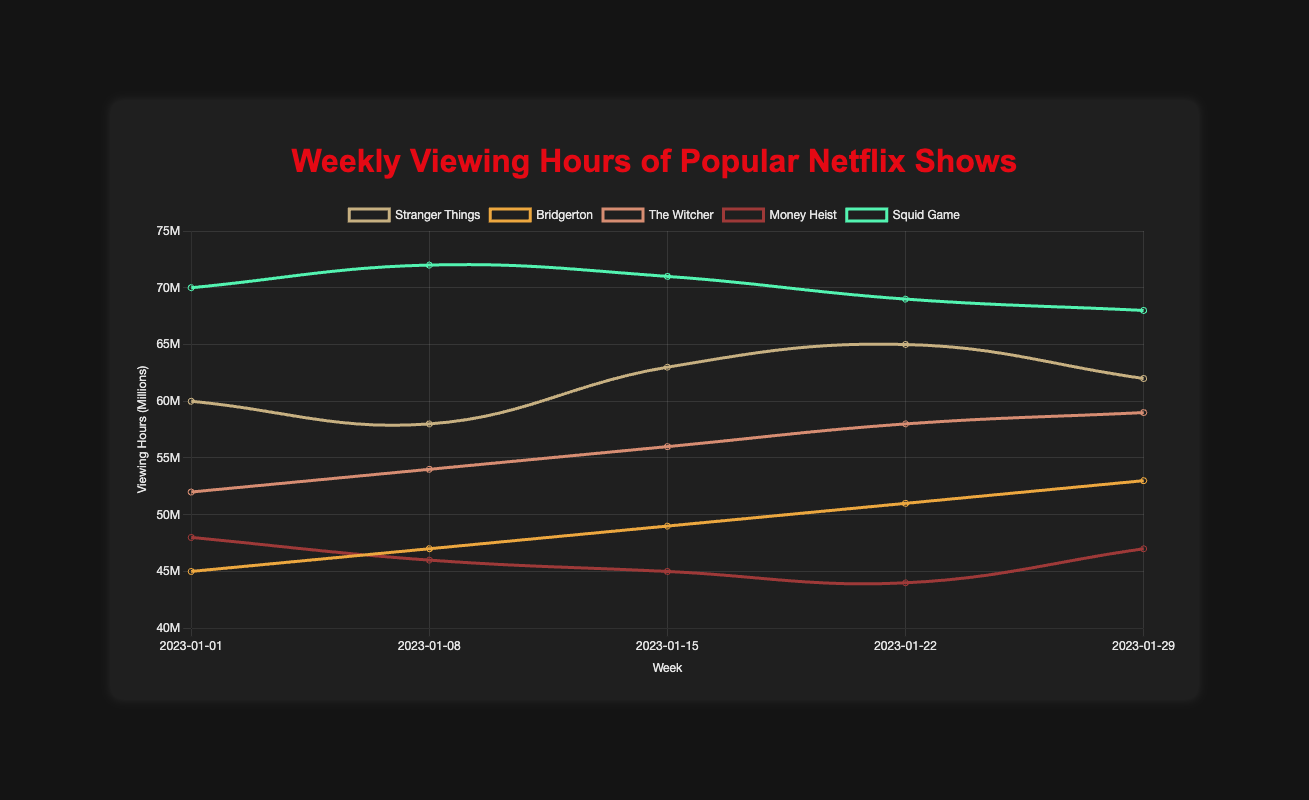Which show had the highest viewing hours at the beginning of January 2023? Look at the viewing hours for the week of "2023-01-01" for each show. "Squid Game" has the highest at 70 million hours.
Answer: Squid Game Which show experienced the greatest increase in viewing hours from January 1 to January 29, 2023? Calculate the difference between the viewing hours on "2023-01-29" and "2023-01-01" for each show: Stranger Things (62000000 - 60000000 = 2000000), Bridgerton (53000000 - 45000000 = 8000000), The Witcher (59000000 - 52000000 = 7000000), Money Heist (47000000 - 48000000 = -1000000), Squid Game (68000000 - 70000000 = -2000000). Bridgerton had the greatest increase.
Answer: Bridgerton By how much did "Stranger Things" viewing hours fluctuate between the highest and lowest points in January 2023? The highest viewing hours for "Stranger Things" was 65 million on "2023-01-22" and the lowest was 58 million on "2023-01-08". The difference is 65 million - 58 million = 7 million.
Answer: 7 million Which show had a consistently increasing trend in viewing hours throughout January 2023? Look at the viewing hours for each show over the weeks. "Bridgerton" shows a consistent increase from 45 million to 53 million over the weeks.
Answer: Bridgerton How did the viewing hours for "Money Heist" change over January 2023? Look at the weekly viewing hours for "Money Heist": 48 million (2023-01-01), 46 million (2023-01-08), 45 million (2023-01-15), 44 million (2023-01-22), 47 million (2023-01-29). It decreased initially then slightly increased at the end.
Answer: Decreased then increased What was the average weekly viewing hours for "The Witcher" in January 2023? Sum the weekly viewing hours of "The Witcher" (52+54+56+58+59 million) = 279 million, then divide by the number of weeks (279 million / 5) = 55.8 million.
Answer: 55.8 million Which two shows had the closest viewing hours in the week of January 29, 2023? Compare the viewing hours of all shows in the week of "2023-01-29": Stranger Things (62 million), Bridgerton (53 million), The Witcher (59 million), Money Heist (47 million), Squid Game (68 million). "Stranger Things" and "The Witcher" had the closest with a difference of (62 million - 59 million) = 3 million.
Answer: Stranger Things and The Witcher 